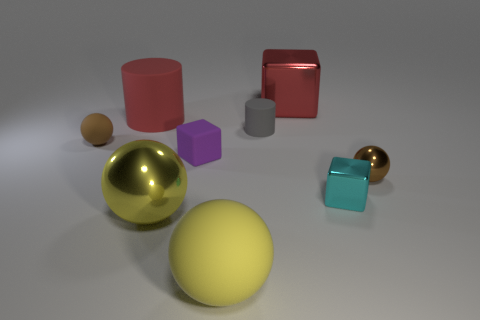What is the material of the brown sphere left of the red thing right of the purple matte thing on the left side of the tiny matte cylinder?
Your answer should be very brief. Rubber. There is a red object in front of the red metallic object; does it have the same size as the cyan cube?
Provide a succinct answer. No. What material is the large red object on the left side of the gray cylinder?
Provide a short and direct response. Rubber. Are there more purple metal objects than tiny shiny spheres?
Give a very brief answer. No. How many things are either large balls that are to the right of the purple matte cube or big purple cylinders?
Provide a short and direct response. 1. What number of tiny gray things are left of the ball that is to the right of the small cyan thing?
Provide a short and direct response. 1. What size is the brown ball that is in front of the brown object that is behind the brown thing in front of the purple rubber block?
Your answer should be very brief. Small. There is a sphere that is to the right of the large red shiny cube; is its color the same as the big metallic sphere?
Offer a very short reply. No. There is another rubber thing that is the same shape as the small brown matte object; what size is it?
Provide a short and direct response. Large. How many objects are either blocks that are behind the gray rubber thing or balls that are behind the cyan thing?
Your response must be concise. 3. 